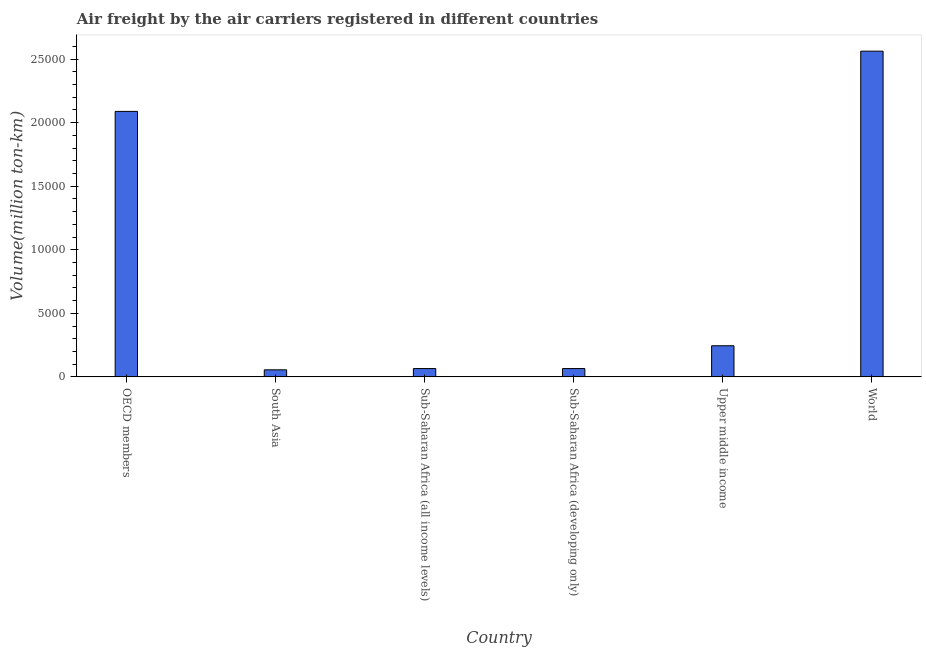Does the graph contain any zero values?
Your answer should be compact. No. Does the graph contain grids?
Your answer should be very brief. No. What is the title of the graph?
Ensure brevity in your answer.  Air freight by the air carriers registered in different countries. What is the label or title of the X-axis?
Your answer should be compact. Country. What is the label or title of the Y-axis?
Make the answer very short. Volume(million ton-km). What is the air freight in Sub-Saharan Africa (all income levels)?
Offer a very short reply. 654.3. Across all countries, what is the maximum air freight?
Keep it short and to the point. 2.56e+04. Across all countries, what is the minimum air freight?
Ensure brevity in your answer.  554.3. In which country was the air freight maximum?
Your answer should be compact. World. What is the sum of the air freight?
Offer a very short reply. 5.08e+04. What is the difference between the air freight in OECD members and Upper middle income?
Provide a succinct answer. 1.84e+04. What is the average air freight per country?
Keep it short and to the point. 8470.65. What is the median air freight?
Provide a succinct answer. 1550.9. In how many countries, is the air freight greater than 23000 million ton-km?
Your answer should be compact. 1. What is the ratio of the air freight in Sub-Saharan Africa (developing only) to that in Upper middle income?
Keep it short and to the point. 0.27. Is the difference between the air freight in OECD members and Sub-Saharan Africa (all income levels) greater than the difference between any two countries?
Your answer should be compact. No. What is the difference between the highest and the second highest air freight?
Make the answer very short. 4739.8. What is the difference between the highest and the lowest air freight?
Provide a succinct answer. 2.51e+04. In how many countries, is the air freight greater than the average air freight taken over all countries?
Your answer should be compact. 2. How many bars are there?
Provide a succinct answer. 6. What is the difference between two consecutive major ticks on the Y-axis?
Offer a very short reply. 5000. Are the values on the major ticks of Y-axis written in scientific E-notation?
Ensure brevity in your answer.  No. What is the Volume(million ton-km) of OECD members?
Provide a succinct answer. 2.09e+04. What is the Volume(million ton-km) of South Asia?
Your response must be concise. 554.3. What is the Volume(million ton-km) in Sub-Saharan Africa (all income levels)?
Keep it short and to the point. 654.3. What is the Volume(million ton-km) in Sub-Saharan Africa (developing only)?
Provide a succinct answer. 654.2. What is the Volume(million ton-km) in Upper middle income?
Your answer should be very brief. 2447.5. What is the Volume(million ton-km) of World?
Provide a short and direct response. 2.56e+04. What is the difference between the Volume(million ton-km) in OECD members and South Asia?
Your answer should be very brief. 2.03e+04. What is the difference between the Volume(million ton-km) in OECD members and Sub-Saharan Africa (all income levels)?
Give a very brief answer. 2.02e+04. What is the difference between the Volume(million ton-km) in OECD members and Sub-Saharan Africa (developing only)?
Keep it short and to the point. 2.02e+04. What is the difference between the Volume(million ton-km) in OECD members and Upper middle income?
Give a very brief answer. 1.84e+04. What is the difference between the Volume(million ton-km) in OECD members and World?
Offer a very short reply. -4739.8. What is the difference between the Volume(million ton-km) in South Asia and Sub-Saharan Africa (all income levels)?
Keep it short and to the point. -100. What is the difference between the Volume(million ton-km) in South Asia and Sub-Saharan Africa (developing only)?
Your answer should be very brief. -99.9. What is the difference between the Volume(million ton-km) in South Asia and Upper middle income?
Give a very brief answer. -1893.2. What is the difference between the Volume(million ton-km) in South Asia and World?
Give a very brief answer. -2.51e+04. What is the difference between the Volume(million ton-km) in Sub-Saharan Africa (all income levels) and Upper middle income?
Provide a succinct answer. -1793.2. What is the difference between the Volume(million ton-km) in Sub-Saharan Africa (all income levels) and World?
Your answer should be compact. -2.50e+04. What is the difference between the Volume(million ton-km) in Sub-Saharan Africa (developing only) and Upper middle income?
Give a very brief answer. -1793.3. What is the difference between the Volume(million ton-km) in Sub-Saharan Africa (developing only) and World?
Your answer should be very brief. -2.50e+04. What is the difference between the Volume(million ton-km) in Upper middle income and World?
Make the answer very short. -2.32e+04. What is the ratio of the Volume(million ton-km) in OECD members to that in South Asia?
Give a very brief answer. 37.68. What is the ratio of the Volume(million ton-km) in OECD members to that in Sub-Saharan Africa (all income levels)?
Offer a very short reply. 31.92. What is the ratio of the Volume(million ton-km) in OECD members to that in Sub-Saharan Africa (developing only)?
Make the answer very short. 31.93. What is the ratio of the Volume(million ton-km) in OECD members to that in Upper middle income?
Your answer should be compact. 8.53. What is the ratio of the Volume(million ton-km) in OECD members to that in World?
Keep it short and to the point. 0.81. What is the ratio of the Volume(million ton-km) in South Asia to that in Sub-Saharan Africa (all income levels)?
Offer a very short reply. 0.85. What is the ratio of the Volume(million ton-km) in South Asia to that in Sub-Saharan Africa (developing only)?
Provide a short and direct response. 0.85. What is the ratio of the Volume(million ton-km) in South Asia to that in Upper middle income?
Provide a short and direct response. 0.23. What is the ratio of the Volume(million ton-km) in South Asia to that in World?
Offer a terse response. 0.02. What is the ratio of the Volume(million ton-km) in Sub-Saharan Africa (all income levels) to that in Sub-Saharan Africa (developing only)?
Your answer should be compact. 1. What is the ratio of the Volume(million ton-km) in Sub-Saharan Africa (all income levels) to that in Upper middle income?
Provide a short and direct response. 0.27. What is the ratio of the Volume(million ton-km) in Sub-Saharan Africa (all income levels) to that in World?
Your answer should be compact. 0.03. What is the ratio of the Volume(million ton-km) in Sub-Saharan Africa (developing only) to that in Upper middle income?
Give a very brief answer. 0.27. What is the ratio of the Volume(million ton-km) in Sub-Saharan Africa (developing only) to that in World?
Your response must be concise. 0.03. What is the ratio of the Volume(million ton-km) in Upper middle income to that in World?
Offer a terse response. 0.1. 